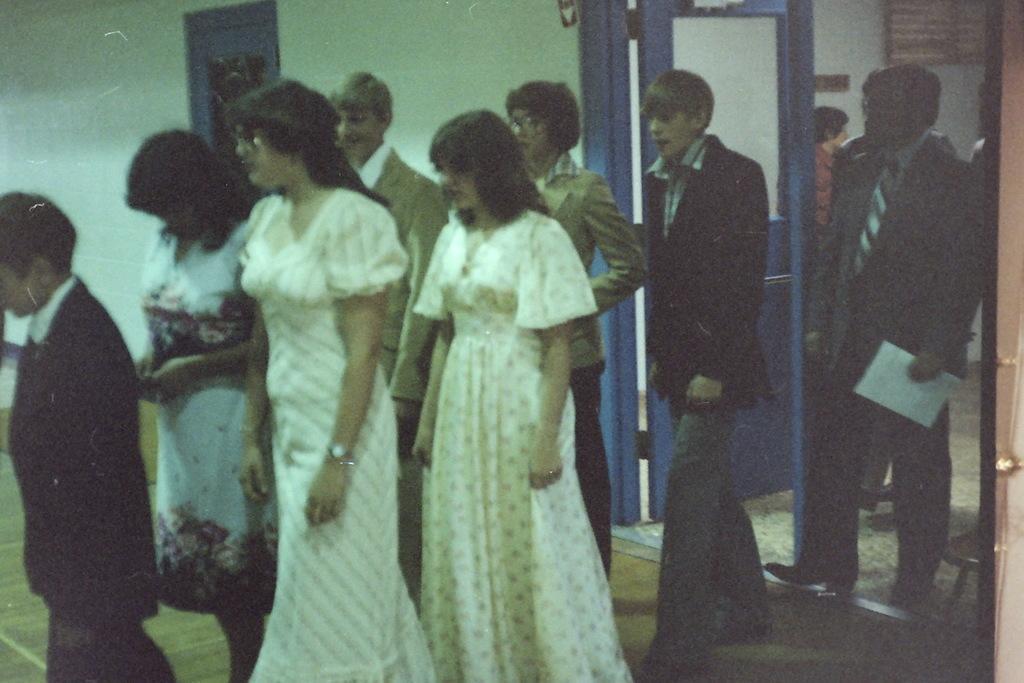In one or two sentences, can you explain what this image depicts? In this image I can see group of people standing. In front the person is wearing white color dress. In the background I can see few doors and the wall is in white color. 